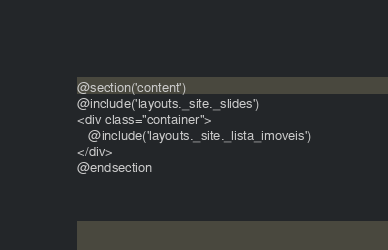<code> <loc_0><loc_0><loc_500><loc_500><_PHP_>@section('content')
@include('layouts._site._slides')
<div class="container">
   @include('layouts._site._lista_imoveis')
</div>
@endsection
</code> 